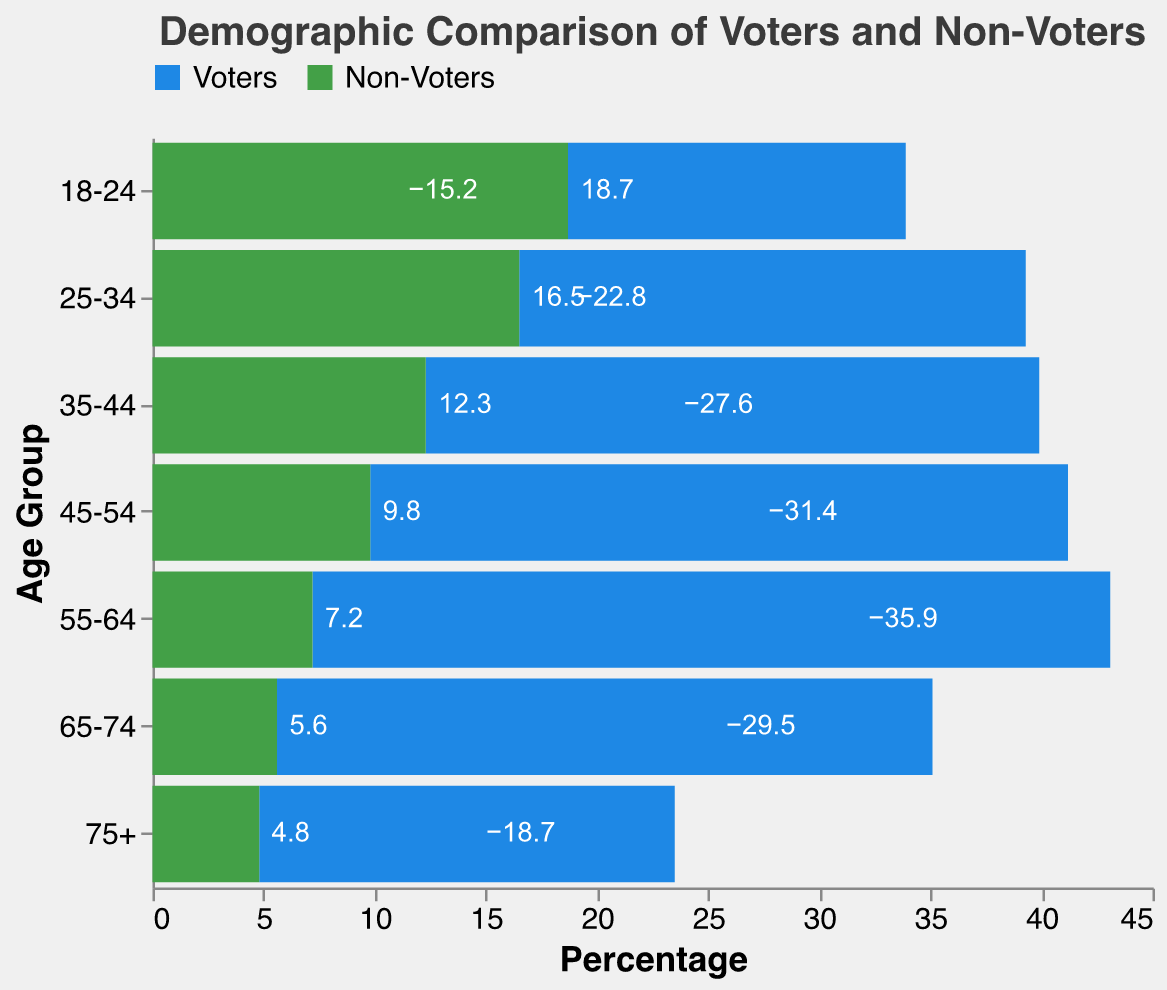What is the title of the figure? The title of the figure is explicitly shown at the top. It reads "Demographic Comparison of Voters and Non-Voters."
Answer: Demographic Comparison of Voters and Non-Voters Which age group has the highest percentage of voters? To find the age group with the highest percentage of voters, look at the bar extensions to the left (negative values) for voters. The 55-64 age group has the longest bar, which indicates the highest percentage at -35.9%.
Answer: 55-64 Which age group has the highest percentage of non-voters? To find the age group with the highest percentage of non-voters, look at the bar extensions to the right (positive values) for non-voters. The 18-24 age group has the longest bar, which indicates the highest percentage at 18.7%.
Answer: 18-24 How does the percentage of voters in the 65-74 age group compare to the percentage of non-voters in the same age group? For the 65-74 age group, the percentage of voters is -29.5%, and the percentage of non-voters is 5.6%. Voters have a significantly higher percentage compared to non-voters.
Answer: Voters > Non-Voters What is the total percentage of voters and non-voters in the 25-34 age group? The percentage of voters in the 25-34 age group is -22.8%, and the percentage of non-voters is 16.5%. Summing these values gives an overall total percentage. (-22.8 + 16.5 = -6.3%)
Answer: -6.3% Are there more voters or non-voters in the 45-54 age group? Compare the absolute percentages of voters and non-voters in the 45-54 age group. Voters have a percentage of -31.4%, and non-voters have a percentage of 9.8%. Since -31.4 is a greater absolute value than 9.8, there are more voters.
Answer: Voters What trend do you observe in the percentage of voters as age increases? Observe the bars for voters (negative values) across age groups. There is an increasing trend in the percentage of voters as age increases, peaking at 55-64, and then decreasing for older age groups.
Answer: Increasing then Decreasing Which category (voters or non-voters) has a generally higher percentage for younger age groups? Compare the bars for the younger age groups (18-24, 25-34, 35-44). Non-voters (positive values) tend to have higher percentages for these age groups than voters (negative values).
Answer: Non-Voters What is the difference in percentage between voters and non-voters in the 55-64 age group? The percentage of voters in the 55-64 age group is -35.9%, and the percentage of non-voters is 7.2%. The difference is calculated as -35.9 - 7.2 = -43.1%.
Answer: -43.1% How does the percentage of non-voters change from the 18-24 age group to the 75+ age group? Observe the non-voter bars for these two age groups. The percentage decreases from 18.7% in the 18-24 age group to 4.8% in the 75+ age group, showing a decreasing trend.
Answer: Decreasing 